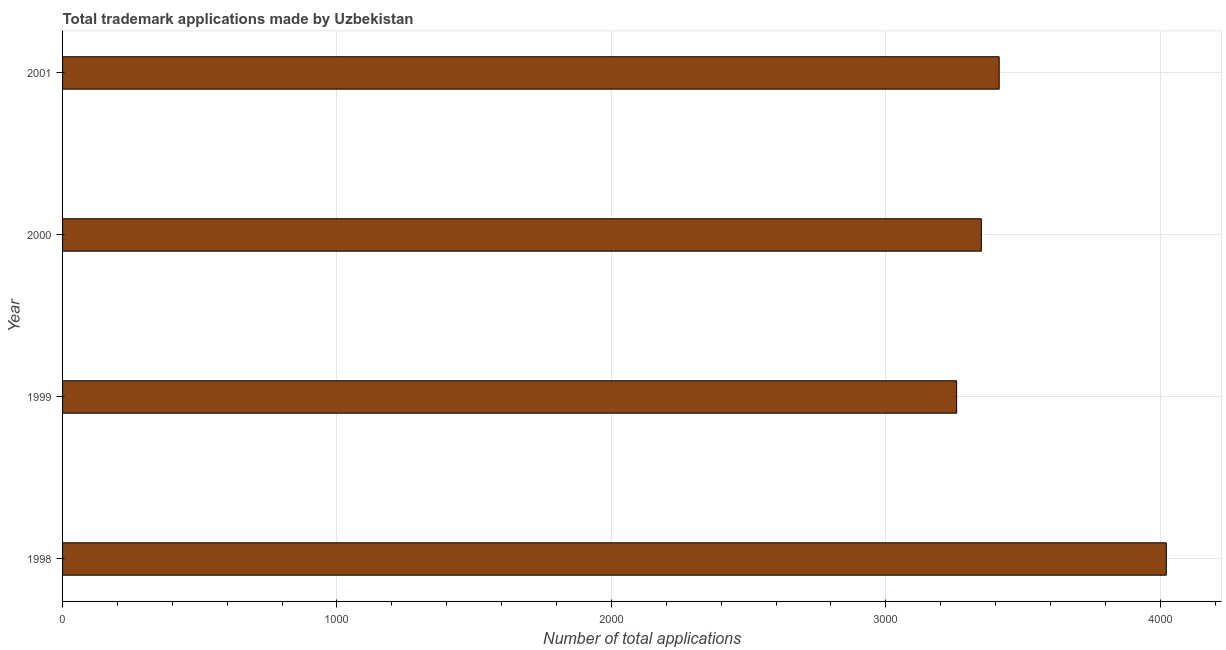Does the graph contain any zero values?
Your response must be concise. No. What is the title of the graph?
Keep it short and to the point. Total trademark applications made by Uzbekistan. What is the label or title of the X-axis?
Keep it short and to the point. Number of total applications. What is the label or title of the Y-axis?
Keep it short and to the point. Year. What is the number of trademark applications in 1998?
Give a very brief answer. 4022. Across all years, what is the maximum number of trademark applications?
Your answer should be compact. 4022. Across all years, what is the minimum number of trademark applications?
Make the answer very short. 3258. In which year was the number of trademark applications maximum?
Your answer should be very brief. 1998. In which year was the number of trademark applications minimum?
Offer a very short reply. 1999. What is the sum of the number of trademark applications?
Offer a very short reply. 1.40e+04. What is the difference between the number of trademark applications in 1999 and 2001?
Your answer should be compact. -155. What is the average number of trademark applications per year?
Make the answer very short. 3510. What is the median number of trademark applications?
Provide a short and direct response. 3380.5. In how many years, is the number of trademark applications greater than 200 ?
Provide a succinct answer. 4. What is the ratio of the number of trademark applications in 2000 to that in 2001?
Give a very brief answer. 0.98. Is the number of trademark applications in 1999 less than that in 2001?
Your answer should be compact. Yes. What is the difference between the highest and the second highest number of trademark applications?
Provide a succinct answer. 609. What is the difference between the highest and the lowest number of trademark applications?
Your answer should be very brief. 764. In how many years, is the number of trademark applications greater than the average number of trademark applications taken over all years?
Offer a terse response. 1. How many bars are there?
Make the answer very short. 4. How many years are there in the graph?
Your answer should be compact. 4. Are the values on the major ticks of X-axis written in scientific E-notation?
Your response must be concise. No. What is the Number of total applications in 1998?
Keep it short and to the point. 4022. What is the Number of total applications in 1999?
Provide a short and direct response. 3258. What is the Number of total applications in 2000?
Your answer should be very brief. 3348. What is the Number of total applications of 2001?
Make the answer very short. 3413. What is the difference between the Number of total applications in 1998 and 1999?
Offer a very short reply. 764. What is the difference between the Number of total applications in 1998 and 2000?
Your answer should be compact. 674. What is the difference between the Number of total applications in 1998 and 2001?
Give a very brief answer. 609. What is the difference between the Number of total applications in 1999 and 2000?
Ensure brevity in your answer.  -90. What is the difference between the Number of total applications in 1999 and 2001?
Offer a terse response. -155. What is the difference between the Number of total applications in 2000 and 2001?
Offer a very short reply. -65. What is the ratio of the Number of total applications in 1998 to that in 1999?
Make the answer very short. 1.23. What is the ratio of the Number of total applications in 1998 to that in 2000?
Offer a very short reply. 1.2. What is the ratio of the Number of total applications in 1998 to that in 2001?
Offer a terse response. 1.18. What is the ratio of the Number of total applications in 1999 to that in 2000?
Your response must be concise. 0.97. What is the ratio of the Number of total applications in 1999 to that in 2001?
Give a very brief answer. 0.95. What is the ratio of the Number of total applications in 2000 to that in 2001?
Give a very brief answer. 0.98. 